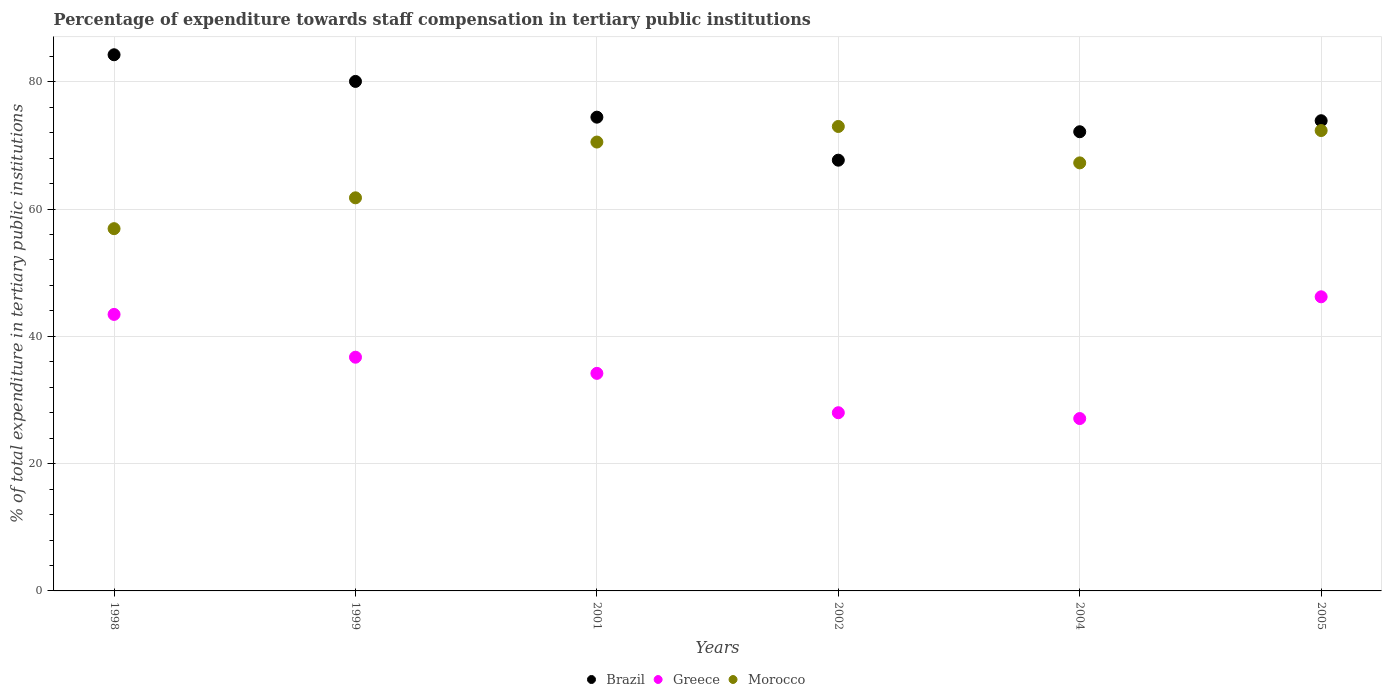Is the number of dotlines equal to the number of legend labels?
Offer a terse response. Yes. What is the percentage of expenditure towards staff compensation in Greece in 2004?
Make the answer very short. 27.09. Across all years, what is the maximum percentage of expenditure towards staff compensation in Brazil?
Offer a terse response. 84.25. Across all years, what is the minimum percentage of expenditure towards staff compensation in Greece?
Keep it short and to the point. 27.09. In which year was the percentage of expenditure towards staff compensation in Brazil maximum?
Offer a very short reply. 1998. What is the total percentage of expenditure towards staff compensation in Brazil in the graph?
Provide a succinct answer. 452.46. What is the difference between the percentage of expenditure towards staff compensation in Greece in 2004 and that in 2005?
Your response must be concise. -19.13. What is the difference between the percentage of expenditure towards staff compensation in Greece in 1998 and the percentage of expenditure towards staff compensation in Brazil in 2005?
Provide a short and direct response. -30.43. What is the average percentage of expenditure towards staff compensation in Morocco per year?
Ensure brevity in your answer.  66.97. In the year 2002, what is the difference between the percentage of expenditure towards staff compensation in Morocco and percentage of expenditure towards staff compensation in Brazil?
Offer a terse response. 5.3. What is the ratio of the percentage of expenditure towards staff compensation in Morocco in 1999 to that in 2005?
Your answer should be very brief. 0.85. What is the difference between the highest and the second highest percentage of expenditure towards staff compensation in Brazil?
Provide a succinct answer. 4.19. What is the difference between the highest and the lowest percentage of expenditure towards staff compensation in Greece?
Make the answer very short. 19.13. Is the sum of the percentage of expenditure towards staff compensation in Greece in 2002 and 2004 greater than the maximum percentage of expenditure towards staff compensation in Morocco across all years?
Offer a very short reply. No. Is it the case that in every year, the sum of the percentage of expenditure towards staff compensation in Brazil and percentage of expenditure towards staff compensation in Morocco  is greater than the percentage of expenditure towards staff compensation in Greece?
Provide a short and direct response. Yes. Is the percentage of expenditure towards staff compensation in Greece strictly greater than the percentage of expenditure towards staff compensation in Brazil over the years?
Your answer should be very brief. No. Is the percentage of expenditure towards staff compensation in Brazil strictly less than the percentage of expenditure towards staff compensation in Greece over the years?
Your response must be concise. No. Does the graph contain grids?
Your answer should be very brief. Yes. Where does the legend appear in the graph?
Give a very brief answer. Bottom center. What is the title of the graph?
Your answer should be very brief. Percentage of expenditure towards staff compensation in tertiary public institutions. Does "Sudan" appear as one of the legend labels in the graph?
Keep it short and to the point. No. What is the label or title of the X-axis?
Offer a very short reply. Years. What is the label or title of the Y-axis?
Your response must be concise. % of total expenditure in tertiary public institutions. What is the % of total expenditure in tertiary public institutions of Brazil in 1998?
Provide a succinct answer. 84.25. What is the % of total expenditure in tertiary public institutions in Greece in 1998?
Provide a short and direct response. 43.45. What is the % of total expenditure in tertiary public institutions in Morocco in 1998?
Give a very brief answer. 56.92. What is the % of total expenditure in tertiary public institutions in Brazil in 1999?
Offer a very short reply. 80.06. What is the % of total expenditure in tertiary public institutions in Greece in 1999?
Ensure brevity in your answer.  36.72. What is the % of total expenditure in tertiary public institutions of Morocco in 1999?
Your answer should be compact. 61.77. What is the % of total expenditure in tertiary public institutions in Brazil in 2001?
Make the answer very short. 74.44. What is the % of total expenditure in tertiary public institutions of Greece in 2001?
Your response must be concise. 34.19. What is the % of total expenditure in tertiary public institutions of Morocco in 2001?
Offer a terse response. 70.53. What is the % of total expenditure in tertiary public institutions of Brazil in 2002?
Keep it short and to the point. 67.68. What is the % of total expenditure in tertiary public institutions of Greece in 2002?
Ensure brevity in your answer.  28. What is the % of total expenditure in tertiary public institutions of Morocco in 2002?
Your answer should be very brief. 72.98. What is the % of total expenditure in tertiary public institutions of Brazil in 2004?
Make the answer very short. 72.15. What is the % of total expenditure in tertiary public institutions in Greece in 2004?
Your response must be concise. 27.09. What is the % of total expenditure in tertiary public institutions in Morocco in 2004?
Provide a short and direct response. 67.26. What is the % of total expenditure in tertiary public institutions of Brazil in 2005?
Make the answer very short. 73.88. What is the % of total expenditure in tertiary public institutions of Greece in 2005?
Your answer should be very brief. 46.22. What is the % of total expenditure in tertiary public institutions in Morocco in 2005?
Offer a terse response. 72.34. Across all years, what is the maximum % of total expenditure in tertiary public institutions of Brazil?
Your answer should be compact. 84.25. Across all years, what is the maximum % of total expenditure in tertiary public institutions of Greece?
Provide a succinct answer. 46.22. Across all years, what is the maximum % of total expenditure in tertiary public institutions in Morocco?
Offer a terse response. 72.98. Across all years, what is the minimum % of total expenditure in tertiary public institutions of Brazil?
Make the answer very short. 67.68. Across all years, what is the minimum % of total expenditure in tertiary public institutions in Greece?
Your answer should be compact. 27.09. Across all years, what is the minimum % of total expenditure in tertiary public institutions in Morocco?
Your response must be concise. 56.92. What is the total % of total expenditure in tertiary public institutions of Brazil in the graph?
Give a very brief answer. 452.46. What is the total % of total expenditure in tertiary public institutions in Greece in the graph?
Your answer should be compact. 215.66. What is the total % of total expenditure in tertiary public institutions of Morocco in the graph?
Make the answer very short. 401.8. What is the difference between the % of total expenditure in tertiary public institutions in Brazil in 1998 and that in 1999?
Your response must be concise. 4.19. What is the difference between the % of total expenditure in tertiary public institutions of Greece in 1998 and that in 1999?
Give a very brief answer. 6.72. What is the difference between the % of total expenditure in tertiary public institutions in Morocco in 1998 and that in 1999?
Make the answer very short. -4.85. What is the difference between the % of total expenditure in tertiary public institutions of Brazil in 1998 and that in 2001?
Offer a very short reply. 9.81. What is the difference between the % of total expenditure in tertiary public institutions in Greece in 1998 and that in 2001?
Your answer should be very brief. 9.26. What is the difference between the % of total expenditure in tertiary public institutions in Morocco in 1998 and that in 2001?
Give a very brief answer. -13.61. What is the difference between the % of total expenditure in tertiary public institutions of Brazil in 1998 and that in 2002?
Offer a very short reply. 16.56. What is the difference between the % of total expenditure in tertiary public institutions in Greece in 1998 and that in 2002?
Your answer should be very brief. 15.45. What is the difference between the % of total expenditure in tertiary public institutions of Morocco in 1998 and that in 2002?
Ensure brevity in your answer.  -16.06. What is the difference between the % of total expenditure in tertiary public institutions of Brazil in 1998 and that in 2004?
Give a very brief answer. 12.1. What is the difference between the % of total expenditure in tertiary public institutions in Greece in 1998 and that in 2004?
Keep it short and to the point. 16.36. What is the difference between the % of total expenditure in tertiary public institutions in Morocco in 1998 and that in 2004?
Your response must be concise. -10.34. What is the difference between the % of total expenditure in tertiary public institutions in Brazil in 1998 and that in 2005?
Ensure brevity in your answer.  10.37. What is the difference between the % of total expenditure in tertiary public institutions in Greece in 1998 and that in 2005?
Provide a succinct answer. -2.77. What is the difference between the % of total expenditure in tertiary public institutions of Morocco in 1998 and that in 2005?
Offer a terse response. -15.42. What is the difference between the % of total expenditure in tertiary public institutions in Brazil in 1999 and that in 2001?
Offer a very short reply. 5.62. What is the difference between the % of total expenditure in tertiary public institutions of Greece in 1999 and that in 2001?
Provide a short and direct response. 2.54. What is the difference between the % of total expenditure in tertiary public institutions of Morocco in 1999 and that in 2001?
Make the answer very short. -8.76. What is the difference between the % of total expenditure in tertiary public institutions in Brazil in 1999 and that in 2002?
Keep it short and to the point. 12.38. What is the difference between the % of total expenditure in tertiary public institutions in Greece in 1999 and that in 2002?
Ensure brevity in your answer.  8.72. What is the difference between the % of total expenditure in tertiary public institutions in Morocco in 1999 and that in 2002?
Give a very brief answer. -11.21. What is the difference between the % of total expenditure in tertiary public institutions of Brazil in 1999 and that in 2004?
Your answer should be compact. 7.91. What is the difference between the % of total expenditure in tertiary public institutions of Greece in 1999 and that in 2004?
Keep it short and to the point. 9.64. What is the difference between the % of total expenditure in tertiary public institutions of Morocco in 1999 and that in 2004?
Your response must be concise. -5.49. What is the difference between the % of total expenditure in tertiary public institutions of Brazil in 1999 and that in 2005?
Provide a succinct answer. 6.18. What is the difference between the % of total expenditure in tertiary public institutions in Greece in 1999 and that in 2005?
Make the answer very short. -9.49. What is the difference between the % of total expenditure in tertiary public institutions in Morocco in 1999 and that in 2005?
Offer a terse response. -10.57. What is the difference between the % of total expenditure in tertiary public institutions of Brazil in 2001 and that in 2002?
Make the answer very short. 6.76. What is the difference between the % of total expenditure in tertiary public institutions of Greece in 2001 and that in 2002?
Your answer should be very brief. 6.18. What is the difference between the % of total expenditure in tertiary public institutions in Morocco in 2001 and that in 2002?
Provide a succinct answer. -2.45. What is the difference between the % of total expenditure in tertiary public institutions of Brazil in 2001 and that in 2004?
Make the answer very short. 2.29. What is the difference between the % of total expenditure in tertiary public institutions in Greece in 2001 and that in 2004?
Your response must be concise. 7.1. What is the difference between the % of total expenditure in tertiary public institutions in Morocco in 2001 and that in 2004?
Provide a short and direct response. 3.27. What is the difference between the % of total expenditure in tertiary public institutions of Brazil in 2001 and that in 2005?
Ensure brevity in your answer.  0.56. What is the difference between the % of total expenditure in tertiary public institutions in Greece in 2001 and that in 2005?
Offer a terse response. -12.03. What is the difference between the % of total expenditure in tertiary public institutions in Morocco in 2001 and that in 2005?
Keep it short and to the point. -1.81. What is the difference between the % of total expenditure in tertiary public institutions of Brazil in 2002 and that in 2004?
Provide a succinct answer. -4.47. What is the difference between the % of total expenditure in tertiary public institutions of Greece in 2002 and that in 2004?
Provide a succinct answer. 0.92. What is the difference between the % of total expenditure in tertiary public institutions in Morocco in 2002 and that in 2004?
Keep it short and to the point. 5.72. What is the difference between the % of total expenditure in tertiary public institutions in Brazil in 2002 and that in 2005?
Your response must be concise. -6.2. What is the difference between the % of total expenditure in tertiary public institutions in Greece in 2002 and that in 2005?
Ensure brevity in your answer.  -18.21. What is the difference between the % of total expenditure in tertiary public institutions in Morocco in 2002 and that in 2005?
Provide a short and direct response. 0.64. What is the difference between the % of total expenditure in tertiary public institutions of Brazil in 2004 and that in 2005?
Your response must be concise. -1.73. What is the difference between the % of total expenditure in tertiary public institutions in Greece in 2004 and that in 2005?
Your answer should be very brief. -19.13. What is the difference between the % of total expenditure in tertiary public institutions of Morocco in 2004 and that in 2005?
Keep it short and to the point. -5.08. What is the difference between the % of total expenditure in tertiary public institutions in Brazil in 1998 and the % of total expenditure in tertiary public institutions in Greece in 1999?
Provide a succinct answer. 47.52. What is the difference between the % of total expenditure in tertiary public institutions of Brazil in 1998 and the % of total expenditure in tertiary public institutions of Morocco in 1999?
Your answer should be very brief. 22.48. What is the difference between the % of total expenditure in tertiary public institutions in Greece in 1998 and the % of total expenditure in tertiary public institutions in Morocco in 1999?
Keep it short and to the point. -18.32. What is the difference between the % of total expenditure in tertiary public institutions in Brazil in 1998 and the % of total expenditure in tertiary public institutions in Greece in 2001?
Ensure brevity in your answer.  50.06. What is the difference between the % of total expenditure in tertiary public institutions in Brazil in 1998 and the % of total expenditure in tertiary public institutions in Morocco in 2001?
Provide a short and direct response. 13.72. What is the difference between the % of total expenditure in tertiary public institutions of Greece in 1998 and the % of total expenditure in tertiary public institutions of Morocco in 2001?
Offer a terse response. -27.08. What is the difference between the % of total expenditure in tertiary public institutions in Brazil in 1998 and the % of total expenditure in tertiary public institutions in Greece in 2002?
Make the answer very short. 56.25. What is the difference between the % of total expenditure in tertiary public institutions of Brazil in 1998 and the % of total expenditure in tertiary public institutions of Morocco in 2002?
Make the answer very short. 11.27. What is the difference between the % of total expenditure in tertiary public institutions in Greece in 1998 and the % of total expenditure in tertiary public institutions in Morocco in 2002?
Ensure brevity in your answer.  -29.53. What is the difference between the % of total expenditure in tertiary public institutions of Brazil in 1998 and the % of total expenditure in tertiary public institutions of Greece in 2004?
Give a very brief answer. 57.16. What is the difference between the % of total expenditure in tertiary public institutions of Brazil in 1998 and the % of total expenditure in tertiary public institutions of Morocco in 2004?
Give a very brief answer. 16.99. What is the difference between the % of total expenditure in tertiary public institutions of Greece in 1998 and the % of total expenditure in tertiary public institutions of Morocco in 2004?
Your answer should be very brief. -23.81. What is the difference between the % of total expenditure in tertiary public institutions in Brazil in 1998 and the % of total expenditure in tertiary public institutions in Greece in 2005?
Offer a terse response. 38.03. What is the difference between the % of total expenditure in tertiary public institutions of Brazil in 1998 and the % of total expenditure in tertiary public institutions of Morocco in 2005?
Provide a short and direct response. 11.91. What is the difference between the % of total expenditure in tertiary public institutions of Greece in 1998 and the % of total expenditure in tertiary public institutions of Morocco in 2005?
Provide a short and direct response. -28.89. What is the difference between the % of total expenditure in tertiary public institutions of Brazil in 1999 and the % of total expenditure in tertiary public institutions of Greece in 2001?
Offer a terse response. 45.87. What is the difference between the % of total expenditure in tertiary public institutions in Brazil in 1999 and the % of total expenditure in tertiary public institutions in Morocco in 2001?
Provide a succinct answer. 9.53. What is the difference between the % of total expenditure in tertiary public institutions of Greece in 1999 and the % of total expenditure in tertiary public institutions of Morocco in 2001?
Give a very brief answer. -33.81. What is the difference between the % of total expenditure in tertiary public institutions in Brazil in 1999 and the % of total expenditure in tertiary public institutions in Greece in 2002?
Provide a succinct answer. 52.06. What is the difference between the % of total expenditure in tertiary public institutions in Brazil in 1999 and the % of total expenditure in tertiary public institutions in Morocco in 2002?
Offer a very short reply. 7.08. What is the difference between the % of total expenditure in tertiary public institutions in Greece in 1999 and the % of total expenditure in tertiary public institutions in Morocco in 2002?
Provide a succinct answer. -36.26. What is the difference between the % of total expenditure in tertiary public institutions in Brazil in 1999 and the % of total expenditure in tertiary public institutions in Greece in 2004?
Your answer should be compact. 52.97. What is the difference between the % of total expenditure in tertiary public institutions of Brazil in 1999 and the % of total expenditure in tertiary public institutions of Morocco in 2004?
Offer a very short reply. 12.8. What is the difference between the % of total expenditure in tertiary public institutions of Greece in 1999 and the % of total expenditure in tertiary public institutions of Morocco in 2004?
Your answer should be very brief. -30.54. What is the difference between the % of total expenditure in tertiary public institutions in Brazil in 1999 and the % of total expenditure in tertiary public institutions in Greece in 2005?
Keep it short and to the point. 33.84. What is the difference between the % of total expenditure in tertiary public institutions in Brazil in 1999 and the % of total expenditure in tertiary public institutions in Morocco in 2005?
Ensure brevity in your answer.  7.72. What is the difference between the % of total expenditure in tertiary public institutions in Greece in 1999 and the % of total expenditure in tertiary public institutions in Morocco in 2005?
Make the answer very short. -35.62. What is the difference between the % of total expenditure in tertiary public institutions of Brazil in 2001 and the % of total expenditure in tertiary public institutions of Greece in 2002?
Your answer should be very brief. 46.44. What is the difference between the % of total expenditure in tertiary public institutions of Brazil in 2001 and the % of total expenditure in tertiary public institutions of Morocco in 2002?
Provide a short and direct response. 1.46. What is the difference between the % of total expenditure in tertiary public institutions in Greece in 2001 and the % of total expenditure in tertiary public institutions in Morocco in 2002?
Your response must be concise. -38.79. What is the difference between the % of total expenditure in tertiary public institutions of Brazil in 2001 and the % of total expenditure in tertiary public institutions of Greece in 2004?
Offer a very short reply. 47.36. What is the difference between the % of total expenditure in tertiary public institutions in Brazil in 2001 and the % of total expenditure in tertiary public institutions in Morocco in 2004?
Offer a very short reply. 7.18. What is the difference between the % of total expenditure in tertiary public institutions in Greece in 2001 and the % of total expenditure in tertiary public institutions in Morocco in 2004?
Provide a short and direct response. -33.07. What is the difference between the % of total expenditure in tertiary public institutions of Brazil in 2001 and the % of total expenditure in tertiary public institutions of Greece in 2005?
Give a very brief answer. 28.23. What is the difference between the % of total expenditure in tertiary public institutions in Brazil in 2001 and the % of total expenditure in tertiary public institutions in Morocco in 2005?
Your answer should be very brief. 2.1. What is the difference between the % of total expenditure in tertiary public institutions in Greece in 2001 and the % of total expenditure in tertiary public institutions in Morocco in 2005?
Give a very brief answer. -38.15. What is the difference between the % of total expenditure in tertiary public institutions in Brazil in 2002 and the % of total expenditure in tertiary public institutions in Greece in 2004?
Offer a very short reply. 40.6. What is the difference between the % of total expenditure in tertiary public institutions in Brazil in 2002 and the % of total expenditure in tertiary public institutions in Morocco in 2004?
Ensure brevity in your answer.  0.42. What is the difference between the % of total expenditure in tertiary public institutions in Greece in 2002 and the % of total expenditure in tertiary public institutions in Morocco in 2004?
Ensure brevity in your answer.  -39.26. What is the difference between the % of total expenditure in tertiary public institutions of Brazil in 2002 and the % of total expenditure in tertiary public institutions of Greece in 2005?
Your answer should be compact. 21.47. What is the difference between the % of total expenditure in tertiary public institutions of Brazil in 2002 and the % of total expenditure in tertiary public institutions of Morocco in 2005?
Provide a short and direct response. -4.66. What is the difference between the % of total expenditure in tertiary public institutions in Greece in 2002 and the % of total expenditure in tertiary public institutions in Morocco in 2005?
Keep it short and to the point. -44.34. What is the difference between the % of total expenditure in tertiary public institutions in Brazil in 2004 and the % of total expenditure in tertiary public institutions in Greece in 2005?
Give a very brief answer. 25.94. What is the difference between the % of total expenditure in tertiary public institutions of Brazil in 2004 and the % of total expenditure in tertiary public institutions of Morocco in 2005?
Provide a short and direct response. -0.19. What is the difference between the % of total expenditure in tertiary public institutions in Greece in 2004 and the % of total expenditure in tertiary public institutions in Morocco in 2005?
Your answer should be very brief. -45.25. What is the average % of total expenditure in tertiary public institutions in Brazil per year?
Your answer should be compact. 75.41. What is the average % of total expenditure in tertiary public institutions in Greece per year?
Ensure brevity in your answer.  35.94. What is the average % of total expenditure in tertiary public institutions in Morocco per year?
Your answer should be very brief. 66.97. In the year 1998, what is the difference between the % of total expenditure in tertiary public institutions of Brazil and % of total expenditure in tertiary public institutions of Greece?
Ensure brevity in your answer.  40.8. In the year 1998, what is the difference between the % of total expenditure in tertiary public institutions of Brazil and % of total expenditure in tertiary public institutions of Morocco?
Provide a succinct answer. 27.32. In the year 1998, what is the difference between the % of total expenditure in tertiary public institutions of Greece and % of total expenditure in tertiary public institutions of Morocco?
Your answer should be compact. -13.48. In the year 1999, what is the difference between the % of total expenditure in tertiary public institutions of Brazil and % of total expenditure in tertiary public institutions of Greece?
Offer a very short reply. 43.34. In the year 1999, what is the difference between the % of total expenditure in tertiary public institutions in Brazil and % of total expenditure in tertiary public institutions in Morocco?
Make the answer very short. 18.29. In the year 1999, what is the difference between the % of total expenditure in tertiary public institutions in Greece and % of total expenditure in tertiary public institutions in Morocco?
Provide a succinct answer. -25.05. In the year 2001, what is the difference between the % of total expenditure in tertiary public institutions of Brazil and % of total expenditure in tertiary public institutions of Greece?
Provide a succinct answer. 40.26. In the year 2001, what is the difference between the % of total expenditure in tertiary public institutions in Brazil and % of total expenditure in tertiary public institutions in Morocco?
Keep it short and to the point. 3.91. In the year 2001, what is the difference between the % of total expenditure in tertiary public institutions in Greece and % of total expenditure in tertiary public institutions in Morocco?
Provide a succinct answer. -36.35. In the year 2002, what is the difference between the % of total expenditure in tertiary public institutions of Brazil and % of total expenditure in tertiary public institutions of Greece?
Ensure brevity in your answer.  39.68. In the year 2002, what is the difference between the % of total expenditure in tertiary public institutions in Brazil and % of total expenditure in tertiary public institutions in Morocco?
Offer a terse response. -5.3. In the year 2002, what is the difference between the % of total expenditure in tertiary public institutions in Greece and % of total expenditure in tertiary public institutions in Morocco?
Your response must be concise. -44.98. In the year 2004, what is the difference between the % of total expenditure in tertiary public institutions in Brazil and % of total expenditure in tertiary public institutions in Greece?
Provide a succinct answer. 45.07. In the year 2004, what is the difference between the % of total expenditure in tertiary public institutions of Brazil and % of total expenditure in tertiary public institutions of Morocco?
Offer a very short reply. 4.89. In the year 2004, what is the difference between the % of total expenditure in tertiary public institutions of Greece and % of total expenditure in tertiary public institutions of Morocco?
Make the answer very short. -40.17. In the year 2005, what is the difference between the % of total expenditure in tertiary public institutions in Brazil and % of total expenditure in tertiary public institutions in Greece?
Provide a short and direct response. 27.67. In the year 2005, what is the difference between the % of total expenditure in tertiary public institutions of Brazil and % of total expenditure in tertiary public institutions of Morocco?
Provide a short and direct response. 1.54. In the year 2005, what is the difference between the % of total expenditure in tertiary public institutions of Greece and % of total expenditure in tertiary public institutions of Morocco?
Make the answer very short. -26.12. What is the ratio of the % of total expenditure in tertiary public institutions in Brazil in 1998 to that in 1999?
Your answer should be compact. 1.05. What is the ratio of the % of total expenditure in tertiary public institutions of Greece in 1998 to that in 1999?
Give a very brief answer. 1.18. What is the ratio of the % of total expenditure in tertiary public institutions of Morocco in 1998 to that in 1999?
Give a very brief answer. 0.92. What is the ratio of the % of total expenditure in tertiary public institutions of Brazil in 1998 to that in 2001?
Your response must be concise. 1.13. What is the ratio of the % of total expenditure in tertiary public institutions of Greece in 1998 to that in 2001?
Provide a short and direct response. 1.27. What is the ratio of the % of total expenditure in tertiary public institutions in Morocco in 1998 to that in 2001?
Your answer should be compact. 0.81. What is the ratio of the % of total expenditure in tertiary public institutions in Brazil in 1998 to that in 2002?
Ensure brevity in your answer.  1.24. What is the ratio of the % of total expenditure in tertiary public institutions in Greece in 1998 to that in 2002?
Offer a very short reply. 1.55. What is the ratio of the % of total expenditure in tertiary public institutions of Morocco in 1998 to that in 2002?
Keep it short and to the point. 0.78. What is the ratio of the % of total expenditure in tertiary public institutions in Brazil in 1998 to that in 2004?
Your answer should be very brief. 1.17. What is the ratio of the % of total expenditure in tertiary public institutions of Greece in 1998 to that in 2004?
Offer a very short reply. 1.6. What is the ratio of the % of total expenditure in tertiary public institutions in Morocco in 1998 to that in 2004?
Provide a short and direct response. 0.85. What is the ratio of the % of total expenditure in tertiary public institutions in Brazil in 1998 to that in 2005?
Your response must be concise. 1.14. What is the ratio of the % of total expenditure in tertiary public institutions in Greece in 1998 to that in 2005?
Ensure brevity in your answer.  0.94. What is the ratio of the % of total expenditure in tertiary public institutions in Morocco in 1998 to that in 2005?
Provide a succinct answer. 0.79. What is the ratio of the % of total expenditure in tertiary public institutions of Brazil in 1999 to that in 2001?
Ensure brevity in your answer.  1.08. What is the ratio of the % of total expenditure in tertiary public institutions of Greece in 1999 to that in 2001?
Give a very brief answer. 1.07. What is the ratio of the % of total expenditure in tertiary public institutions of Morocco in 1999 to that in 2001?
Offer a very short reply. 0.88. What is the ratio of the % of total expenditure in tertiary public institutions in Brazil in 1999 to that in 2002?
Ensure brevity in your answer.  1.18. What is the ratio of the % of total expenditure in tertiary public institutions in Greece in 1999 to that in 2002?
Provide a short and direct response. 1.31. What is the ratio of the % of total expenditure in tertiary public institutions in Morocco in 1999 to that in 2002?
Your response must be concise. 0.85. What is the ratio of the % of total expenditure in tertiary public institutions in Brazil in 1999 to that in 2004?
Your response must be concise. 1.11. What is the ratio of the % of total expenditure in tertiary public institutions in Greece in 1999 to that in 2004?
Your response must be concise. 1.36. What is the ratio of the % of total expenditure in tertiary public institutions of Morocco in 1999 to that in 2004?
Ensure brevity in your answer.  0.92. What is the ratio of the % of total expenditure in tertiary public institutions of Brazil in 1999 to that in 2005?
Your answer should be very brief. 1.08. What is the ratio of the % of total expenditure in tertiary public institutions in Greece in 1999 to that in 2005?
Provide a succinct answer. 0.79. What is the ratio of the % of total expenditure in tertiary public institutions of Morocco in 1999 to that in 2005?
Make the answer very short. 0.85. What is the ratio of the % of total expenditure in tertiary public institutions in Brazil in 2001 to that in 2002?
Your answer should be very brief. 1.1. What is the ratio of the % of total expenditure in tertiary public institutions of Greece in 2001 to that in 2002?
Ensure brevity in your answer.  1.22. What is the ratio of the % of total expenditure in tertiary public institutions of Morocco in 2001 to that in 2002?
Give a very brief answer. 0.97. What is the ratio of the % of total expenditure in tertiary public institutions in Brazil in 2001 to that in 2004?
Keep it short and to the point. 1.03. What is the ratio of the % of total expenditure in tertiary public institutions in Greece in 2001 to that in 2004?
Offer a terse response. 1.26. What is the ratio of the % of total expenditure in tertiary public institutions in Morocco in 2001 to that in 2004?
Your answer should be compact. 1.05. What is the ratio of the % of total expenditure in tertiary public institutions in Brazil in 2001 to that in 2005?
Your answer should be very brief. 1.01. What is the ratio of the % of total expenditure in tertiary public institutions of Greece in 2001 to that in 2005?
Offer a very short reply. 0.74. What is the ratio of the % of total expenditure in tertiary public institutions in Brazil in 2002 to that in 2004?
Offer a terse response. 0.94. What is the ratio of the % of total expenditure in tertiary public institutions in Greece in 2002 to that in 2004?
Your response must be concise. 1.03. What is the ratio of the % of total expenditure in tertiary public institutions in Morocco in 2002 to that in 2004?
Offer a terse response. 1.08. What is the ratio of the % of total expenditure in tertiary public institutions of Brazil in 2002 to that in 2005?
Offer a terse response. 0.92. What is the ratio of the % of total expenditure in tertiary public institutions of Greece in 2002 to that in 2005?
Your answer should be compact. 0.61. What is the ratio of the % of total expenditure in tertiary public institutions of Morocco in 2002 to that in 2005?
Offer a terse response. 1.01. What is the ratio of the % of total expenditure in tertiary public institutions in Brazil in 2004 to that in 2005?
Keep it short and to the point. 0.98. What is the ratio of the % of total expenditure in tertiary public institutions in Greece in 2004 to that in 2005?
Ensure brevity in your answer.  0.59. What is the ratio of the % of total expenditure in tertiary public institutions in Morocco in 2004 to that in 2005?
Your answer should be compact. 0.93. What is the difference between the highest and the second highest % of total expenditure in tertiary public institutions in Brazil?
Provide a short and direct response. 4.19. What is the difference between the highest and the second highest % of total expenditure in tertiary public institutions in Greece?
Offer a very short reply. 2.77. What is the difference between the highest and the second highest % of total expenditure in tertiary public institutions of Morocco?
Offer a very short reply. 0.64. What is the difference between the highest and the lowest % of total expenditure in tertiary public institutions of Brazil?
Your answer should be very brief. 16.56. What is the difference between the highest and the lowest % of total expenditure in tertiary public institutions of Greece?
Ensure brevity in your answer.  19.13. What is the difference between the highest and the lowest % of total expenditure in tertiary public institutions in Morocco?
Give a very brief answer. 16.06. 